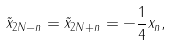<formula> <loc_0><loc_0><loc_500><loc_500>\tilde { x } _ { 2 N - n } = \tilde { x } _ { 2 N + n } = - \frac { 1 } { 4 } x _ { n } ,</formula> 